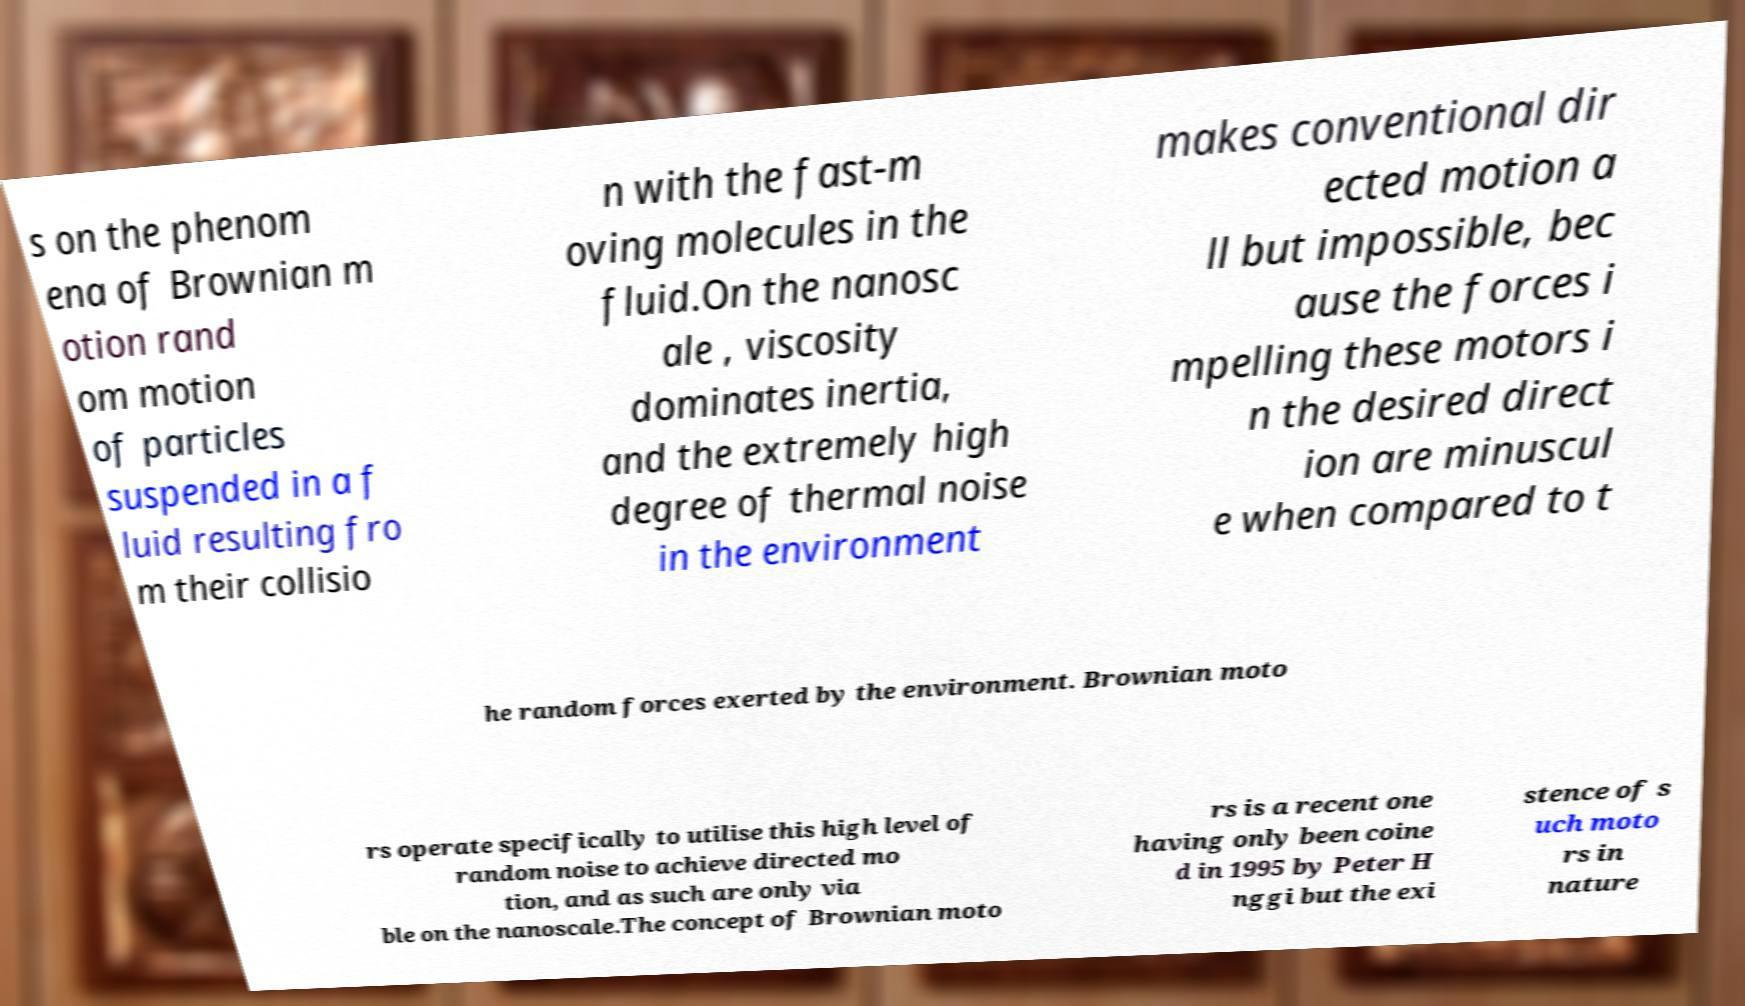Please identify and transcribe the text found in this image. s on the phenom ena of Brownian m otion rand om motion of particles suspended in a f luid resulting fro m their collisio n with the fast-m oving molecules in the fluid.On the nanosc ale , viscosity dominates inertia, and the extremely high degree of thermal noise in the environment makes conventional dir ected motion a ll but impossible, bec ause the forces i mpelling these motors i n the desired direct ion are minuscul e when compared to t he random forces exerted by the environment. Brownian moto rs operate specifically to utilise this high level of random noise to achieve directed mo tion, and as such are only via ble on the nanoscale.The concept of Brownian moto rs is a recent one having only been coine d in 1995 by Peter H nggi but the exi stence of s uch moto rs in nature 